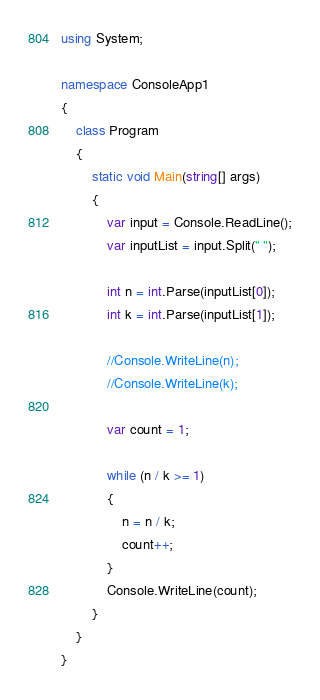<code> <loc_0><loc_0><loc_500><loc_500><_C#_>using System;

namespace ConsoleApp1
{
    class Program
    {
        static void Main(string[] args)
        {
            var input = Console.ReadLine();
            var inputList = input.Split(" ");

            int n = int.Parse(inputList[0]);
            int k = int.Parse(inputList[1]);

            //Console.WriteLine(n);
            //Console.WriteLine(k);

            var count = 1;

            while (n / k >= 1)
            {
                n = n / k;
                count++;
            }
            Console.WriteLine(count);
        }
    }
}
</code> 